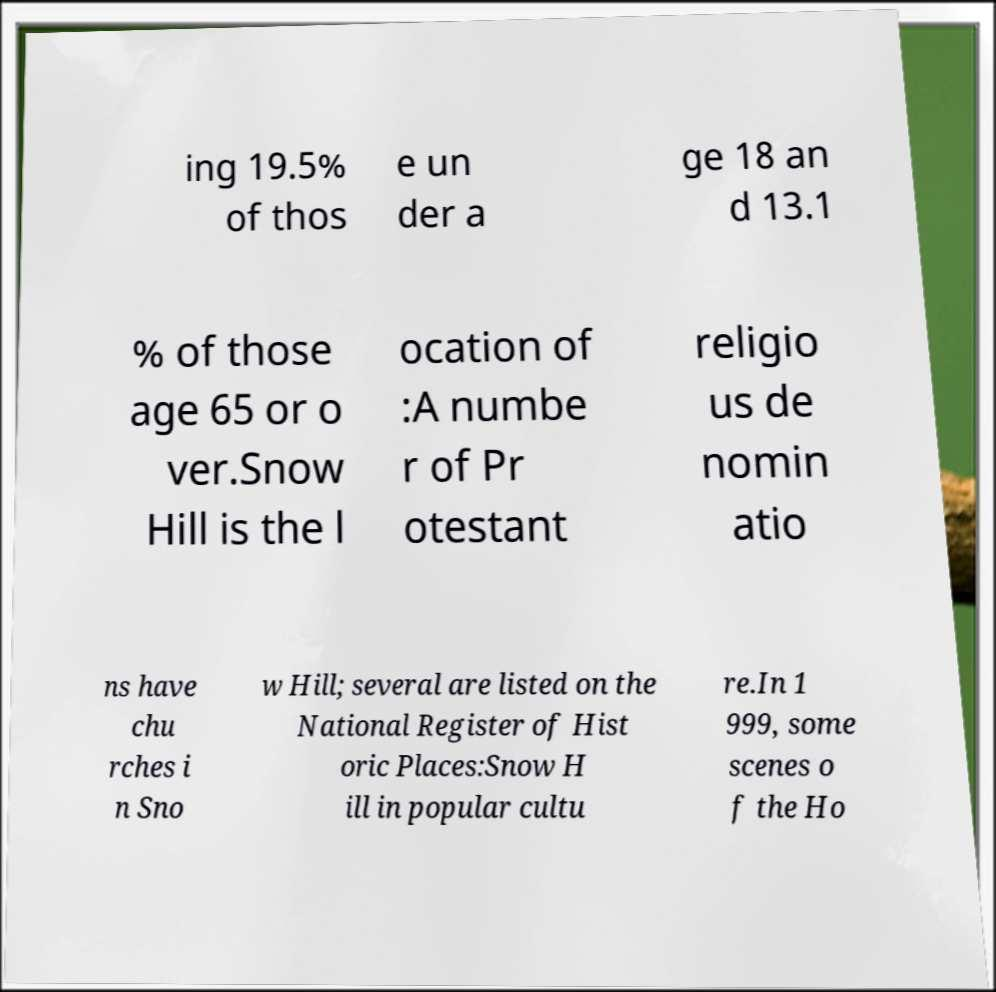I need the written content from this picture converted into text. Can you do that? ing 19.5% of thos e un der a ge 18 an d 13.1 % of those age 65 or o ver.Snow Hill is the l ocation of :A numbe r of Pr otestant religio us de nomin atio ns have chu rches i n Sno w Hill; several are listed on the National Register of Hist oric Places:Snow H ill in popular cultu re.In 1 999, some scenes o f the Ho 